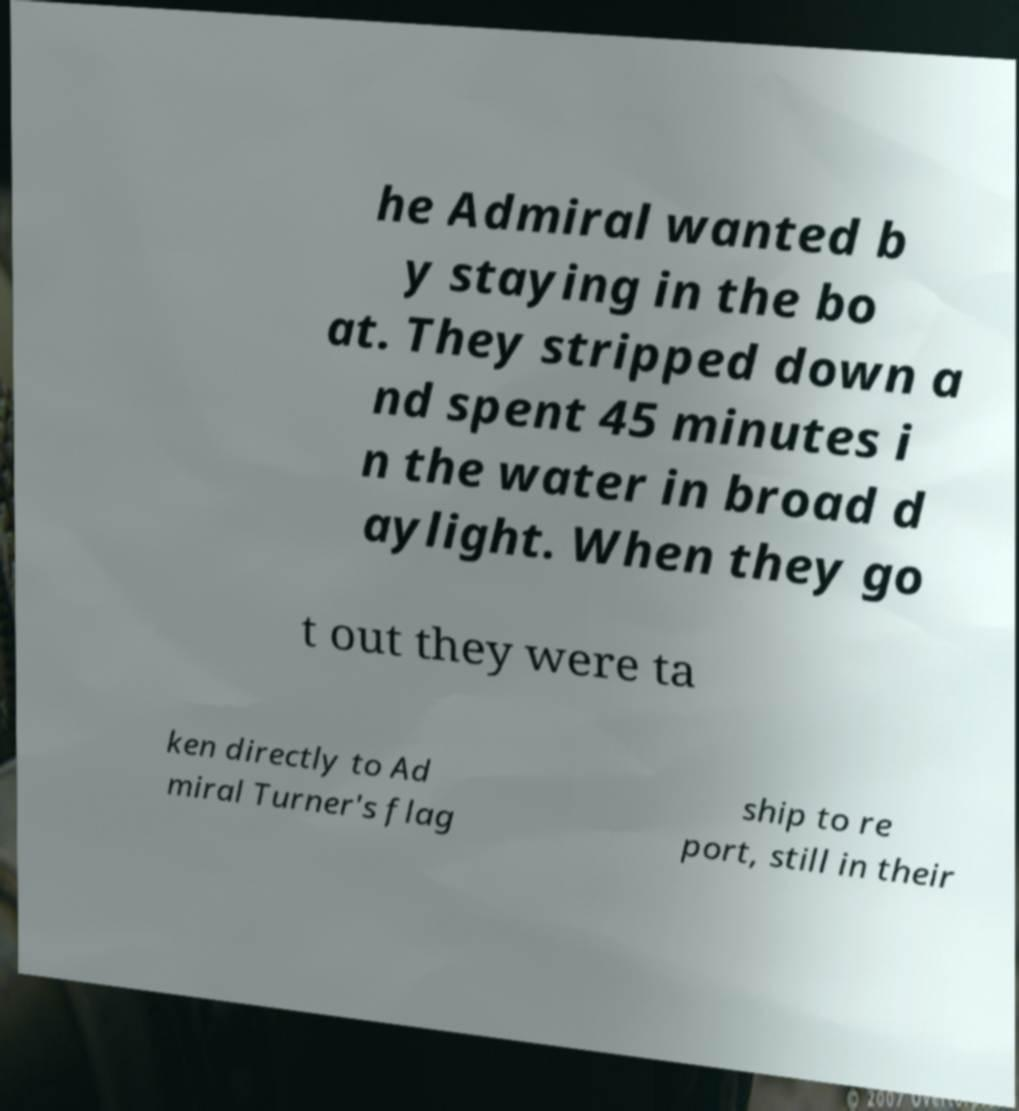Could you assist in decoding the text presented in this image and type it out clearly? he Admiral wanted b y staying in the bo at. They stripped down a nd spent 45 minutes i n the water in broad d aylight. When they go t out they were ta ken directly to Ad miral Turner's flag ship to re port, still in their 